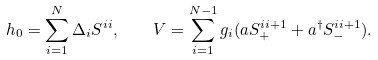<formula> <loc_0><loc_0><loc_500><loc_500>h _ { 0 } = \sum _ { i = 1 } ^ { N } \Delta _ { i } S ^ { i i } , \quad V = \sum _ { i = 1 } ^ { N - 1 } g _ { i } ( a S _ { + } ^ { i i + 1 } + a ^ { \dagger } S _ { - } ^ { i i + 1 } ) .</formula> 